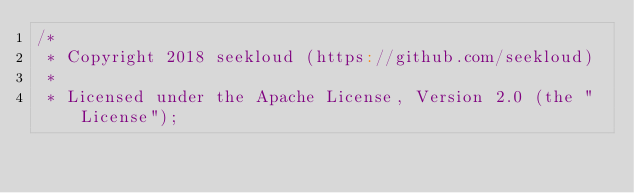<code> <loc_0><loc_0><loc_500><loc_500><_Scala_>/*
 * Copyright 2018 seekloud (https://github.com/seekloud)
 *
 * Licensed under the Apache License, Version 2.0 (the "License");</code> 